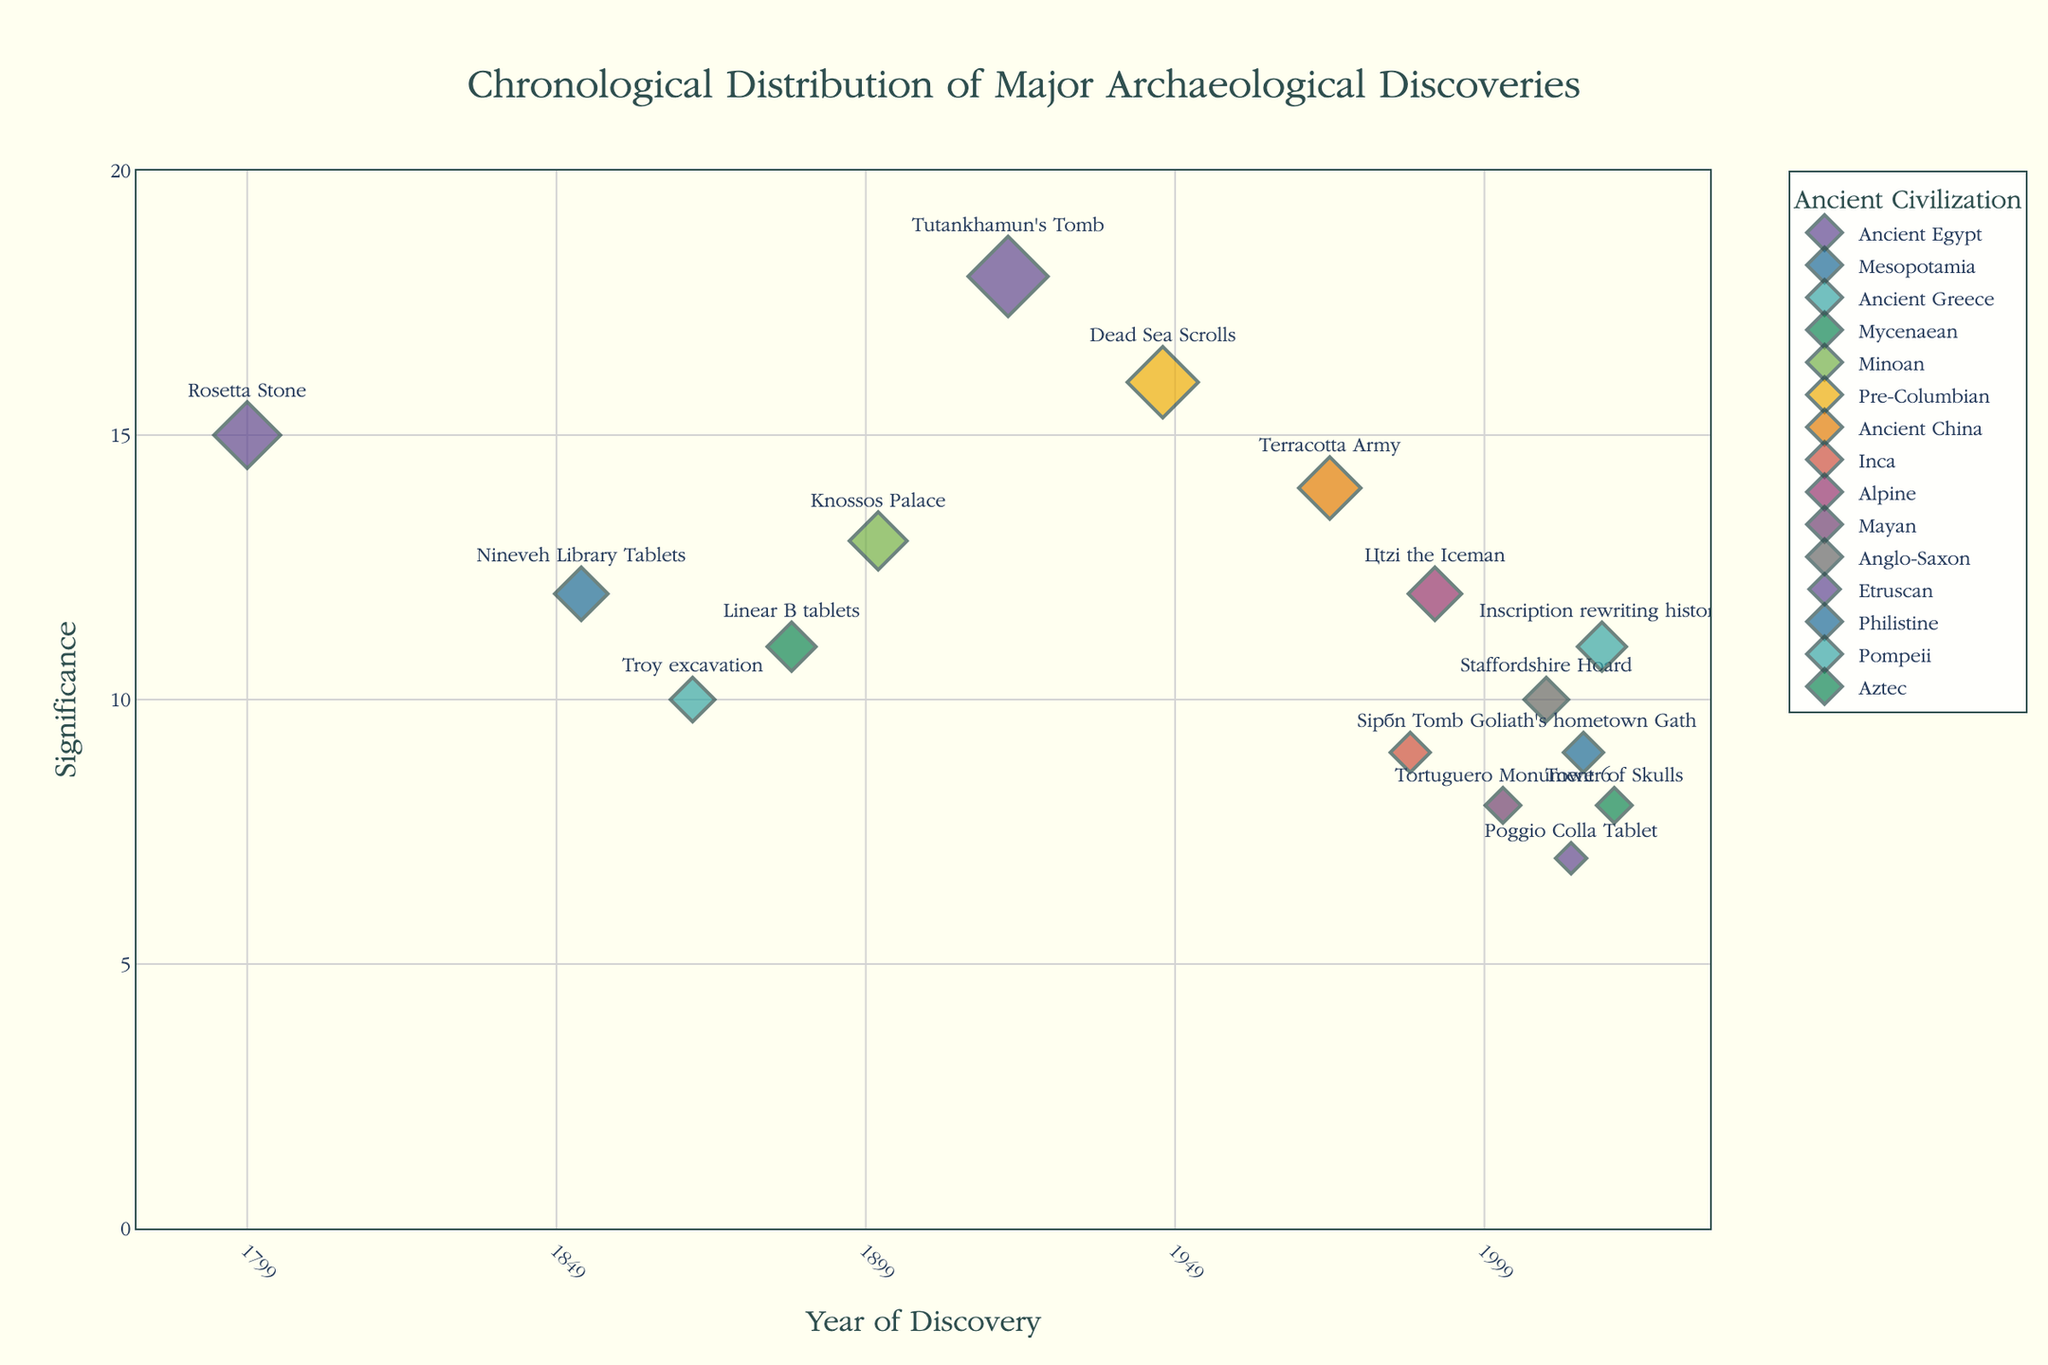What is the title of the plot? The title of the plot is displayed at the top center and generally provides a description of what the plot represents. In this case, it reads "Chronological Distribution of Major Archaeological Discoveries".
Answer: Chronological Distribution of Major Archaeological Discoveries How many distinct ancient civilizations are depicted in the plot? The plot uses different colors for each ancient civilization represented in the data, and each is named in the legend on the right side. By counting these categories, we can find the number of distinct civilizations.
Answer: 14 Which discovery has the highest significance? On the plot, the significance is indicated by both the y-axis and the size of the markers. The largest marker appears at the highest point along the y-axis. This represents Tutankhamun's Tomb discovered in 1922 with a significance of 18.
Answer: Tutankhamun's Tomb What is the most recent discovery in the plot and its corresponding significance? The points on the x-axis are arranged chronologically. The rightmost point on the x-axis represents the most recent discovery. From the plot, the most recent discovery is the Tower of Skulls found in 2020, and its significance is 8.
Answer: Tower of Skulls, significance 8 Which ancient civilization has the earliest discovery and what is it? By observing the leftmost marker on the x-axis, which indicates the earliest discovery in the timeline, we can see that the Rosetta Stone, associated with Ancient Egypt, is the earliest discovery dated to 1799.
Answer: Ancient Egypt, Rosetta Stone Compare the significance of the Rosetta Stone and Nineveh Library Tablets discoveries. Which one is more significant? By identifying the points corresponding to these discoveries, we can see that the significance values for the Rosetta Stone and Nineveh Library Tablets are 15 and 12, respectively. Therefore, the Rosetta Stone is more significant.
Answer: Rosetta Stone What is the average significance of discoveries related to Ancient Egypt? To calculate the average significance for Ancient Egypt, sum the significance values of all its discoveries and then divide by the number of those discoveries. The Ancient Egypt discoveries have significances 15 and 18. Average is (15+18)/2 = 16.5.
Answer: 16.5 Which civilization has the highest number of discoveries shown in the plot? Count the number of markers corresponding to each civilization by observing the legend and markers on the plot. The civilization with the most markers is Ancient Egypt, with two discoveries.
Answer: Ancient Egypt How many discoveries in the plot have a significance of 10 or higher? To determine this, count the markers on the plot that are positioned at or above the y-axis value of 10.
Answer: 10 Who discovered Ötzi the Iceman, and in what year was it discovered? By identifying the marker with the associated text for Ötzi the Iceman, we see it was discovered by observing the year written alongside the marker. It is associated with the Alpine and discovered in 1991.
Answer: Ötzi the Iceman, 1991 